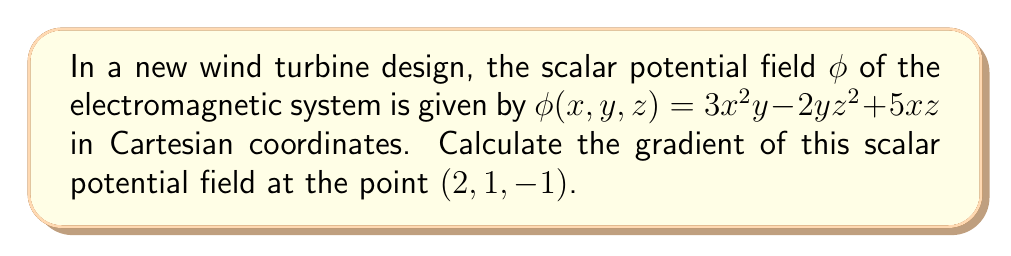Solve this math problem. To solve this problem, we'll follow these steps:

1) The gradient of a scalar potential field $\phi(x,y,z)$ is defined as:

   $$\nabla \phi = \left(\frac{\partial \phi}{\partial x}, \frac{\partial \phi}{\partial y}, \frac{\partial \phi}{\partial z}\right)$$

2) Let's calculate each partial derivative:

   $\frac{\partial \phi}{\partial x} = 6xy + 5z$
   $\frac{\partial \phi}{\partial y} = 3x^2 - 2z^2$
   $\frac{\partial \phi}{\partial z} = -4yz + 5x$

3) Now we substitute the given point $(2, 1, -1)$ into each partial derivative:

   $\frac{\partial \phi}{\partial x}|_{(2,1,-1)} = 6(2)(1) + 5(-1) = 7$
   $\frac{\partial \phi}{\partial y}|_{(2,1,-1)} = 3(2)^2 - 2(-1)^2 = 10$
   $\frac{\partial \phi}{\partial z}|_{(2,1,-1)} = -4(1)(-1) + 5(2) = 14$

4) Therefore, the gradient at the point $(2, 1, -1)$ is:

   $$\nabla \phi|_{(2,1,-1)} = (7, 10, 14)$$

This vector represents the direction and magnitude of the steepest increase in the scalar potential field at the given point in the wind turbine's electromagnetic system.
Answer: $(7, 10, 14)$ 